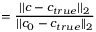<formula> <loc_0><loc_0><loc_500><loc_500>= \frac { | | c - c _ { t r u e } | | _ { 2 } } { | | c _ { 0 } - c _ { t r u e } | | _ { 2 } }</formula> 